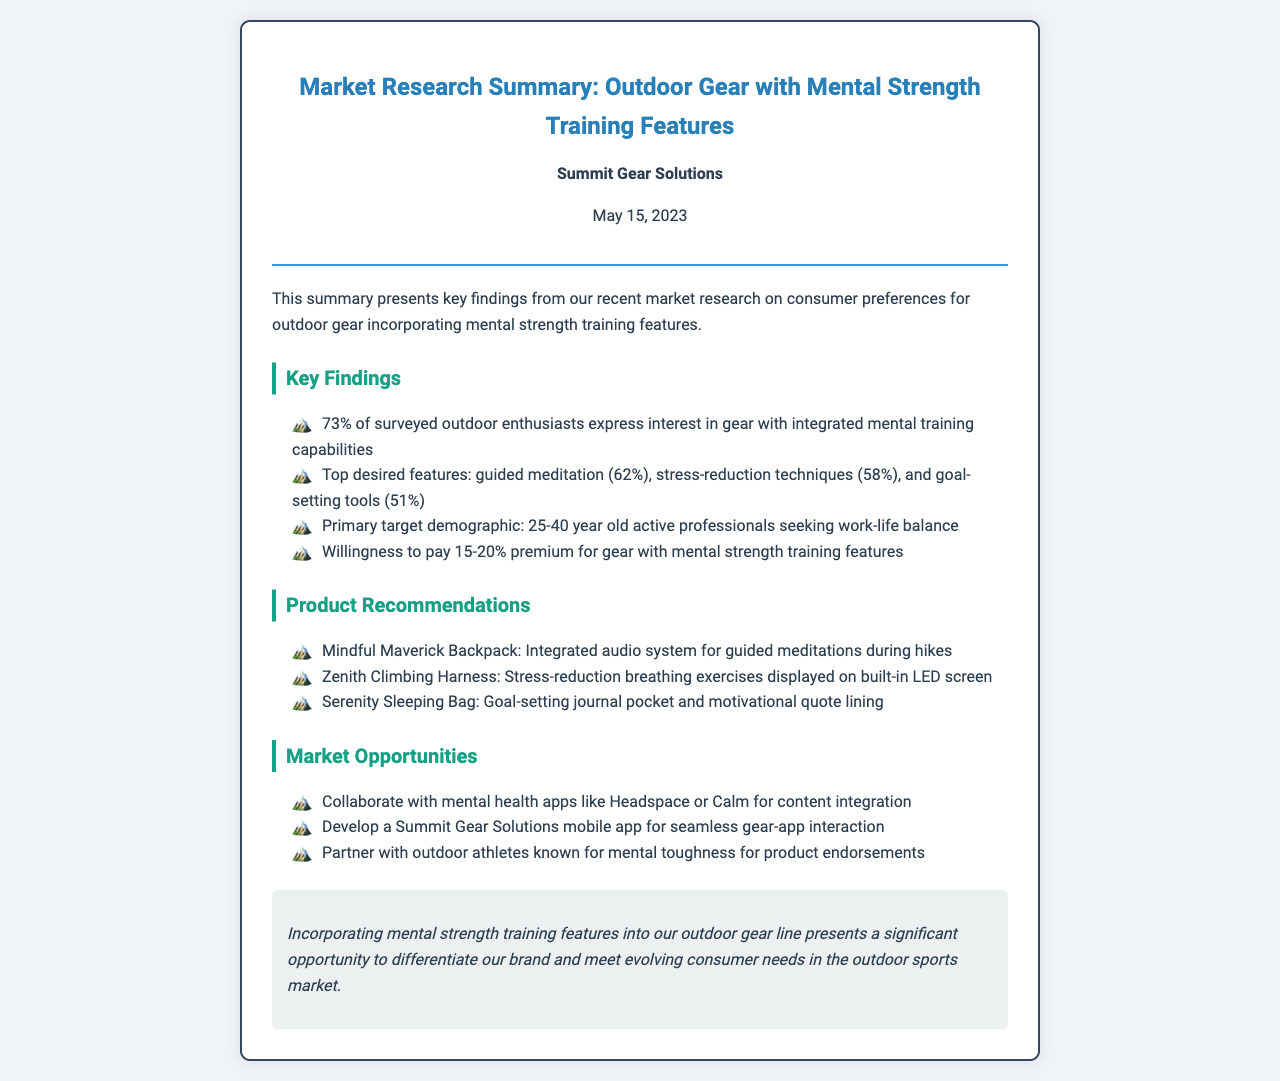What percentage of outdoor enthusiasts are interested in gear with mental training capabilities? The document states that 73% of surveyed outdoor enthusiasts express interest in gear with integrated mental training capabilities.
Answer: 73% What are the top desired features for outdoor gear according to the research? The document lists guided meditation, stress-reduction techniques, and goal-setting tools as the top desired features for outdoor gear.
Answer: Guided meditation, stress-reduction techniques, goal-setting tools What is the primary target demographic listed in the research? The document identifies the primary target demographic as active professionals aged 25-40.
Answer: 25-40 year old active professionals What premium percentage are consumers willing to pay for gear with mental strength training features? The document mentions that consumers are willing to pay a 15-20% premium for such gear.
Answer: 15-20% What is the name of the product recommended with integrated audio system for guided meditations? The document identifies the "Mindful Maverick Backpack" as the product with this feature.
Answer: Mindful Maverick Backpack Which mental health apps are suggested for collaboration in the market opportunities? The document suggests collaborating with apps like Headspace or Calm for content integration.
Answer: Headspace, Calm What is one feature of the "Zenith Climbing Harness"? The document states that it has stress-reduction breathing exercises displayed on a built-in LED screen.
Answer: Stress-reduction breathing exercises What key opportunity does the conclusion suggest regarding brand differentiation? The conclusion highlights incorporating mental strength training features as a significant opportunity to differentiate the brand.
Answer: Differentiate our brand What is the date of the market research summary? The document specifies that the market research summary was published on May 15, 2023.
Answer: May 15, 2023 